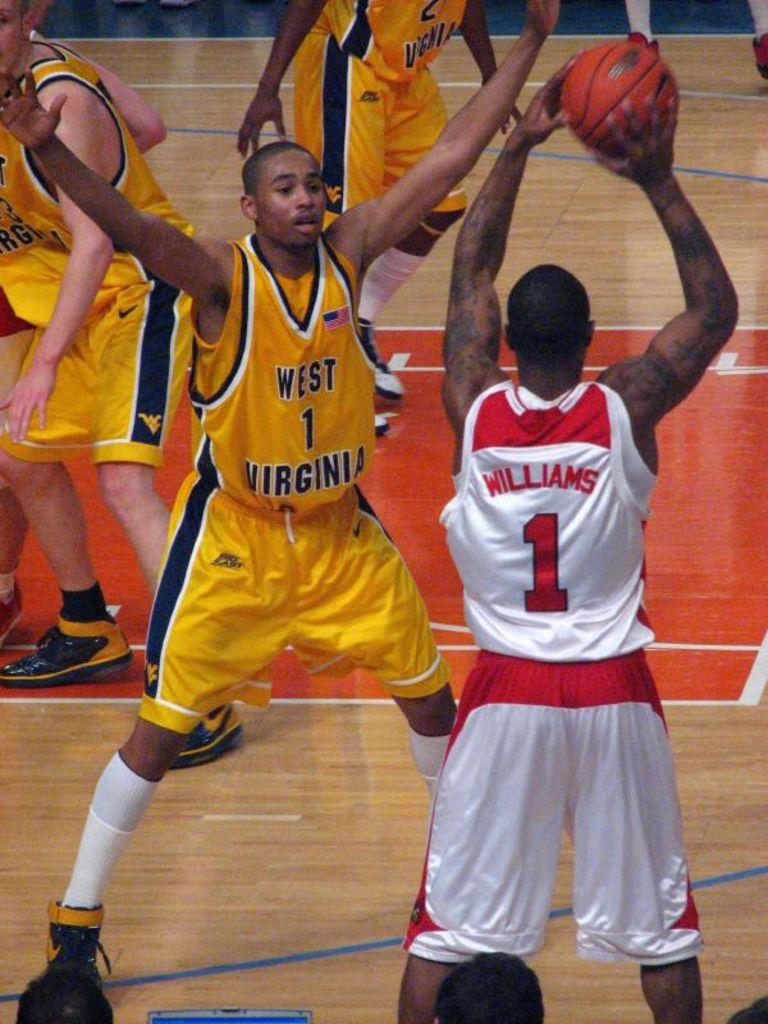<image>
Render a clear and concise summary of the photo. Williams, in the red and white number 1 jersey, looks for someone to whom he can pass the ball. 